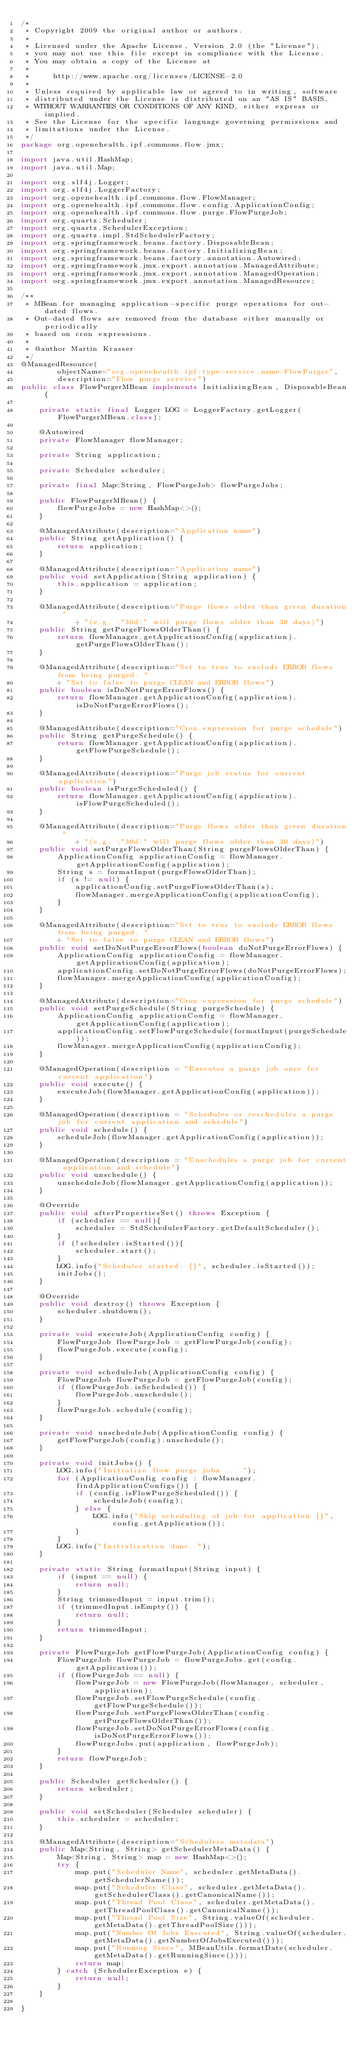Convert code to text. <code><loc_0><loc_0><loc_500><loc_500><_Java_>/*
 * Copyright 2009 the original author or authors.
 * 
 * Licensed under the Apache License, Version 2.0 (the "License");
 * you may not use this file except in compliance with the License.
 * You may obtain a copy of the License at
 *
 *     http://www.apache.org/licenses/LICENSE-2.0
 *     
 * Unless required by applicable law or agreed to in writing, software
 * distributed under the License is distributed on an "AS IS" BASIS,
 * WITHOUT WARRANTIES OR CONDITIONS OF ANY KIND, either express or implied.
 * See the License for the specific language governing permissions and
 * limitations under the License.
 */
package org.openehealth.ipf.commons.flow.jmx;

import java.util.HashMap;
import java.util.Map;

import org.slf4j.Logger;
import org.slf4j.LoggerFactory;
import org.openehealth.ipf.commons.flow.FlowManager;
import org.openehealth.ipf.commons.flow.config.ApplicationConfig;
import org.openehealth.ipf.commons.flow.purge.FlowPurgeJob;
import org.quartz.Scheduler;
import org.quartz.SchedulerException;
import org.quartz.impl.StdSchedulerFactory;
import org.springframework.beans.factory.DisposableBean;
import org.springframework.beans.factory.InitializingBean;
import org.springframework.beans.factory.annotation.Autowired;
import org.springframework.jmx.export.annotation.ManagedAttribute;
import org.springframework.jmx.export.annotation.ManagedOperation;
import org.springframework.jmx.export.annotation.ManagedResource;

/**
 * MBean for managing application-specific purge operations for out-dated flows.
 * Out-dated flows are removed from the database either manually or periodically
 * based on cron expressions.
 * 
 * @author Martin Krasser
 */
@ManagedResource(
        objectName="org.openehealth.ipf:type=service,name=FlowPurger",
        description="Flow purge service") 
public class FlowPurgerMBean implements InitializingBean, DisposableBean {

    private static final Logger LOG = LoggerFactory.getLogger(FlowPurgerMBean.class);

    @Autowired
    private FlowManager flowManager; 

    private String application; 

    private Scheduler scheduler;
    
    private final Map<String, FlowPurgeJob> flowPurgeJobs;

    public FlowPurgerMBean() {
        flowPurgeJobs = new HashMap<>();
    }

    @ManagedAttribute(description="Application name")
    public String getApplication() {
        return application;
    }

    @ManagedAttribute(description="Application name")
    public void setApplication(String application) {
        this.application = application;
    }

    @ManagedAttribute(description="Purge flows older than given duration "
            + "(e.g. \"30d\" will purge flows older than 30 days)")
    public String getPurgeFlowsOlderThan() {
        return flowManager.getApplicationConfig(application).getPurgeFlowsOlderThan();
    }

    @ManagedAttribute(description="Set to true to exclude ERROR flows from being purged. "
        + "Set to false to purge CLEAN and ERROR flows")
    public boolean isDoNotPurgeErrorFlows() {
        return flowManager.getApplicationConfig(application).isDoNotPurgeErrorFlows();
    }

    @ManagedAttribute(description="Cron expression for purge schedule")
    public String getPurgeSchedule() {
        return flowManager.getApplicationConfig(application).getFlowPurgeSchedule();
    }

    @ManagedAttribute(description="Purge job status for current application")
    public boolean isPurgeScheduled() {
        return flowManager.getApplicationConfig(application).isFlowPurgeScheduled();
    }

    @ManagedAttribute(description="Purge flows older than given duration "
            + "(e.g. \"30d\" will purge flows older than 30 days)")
    public void setPurgeFlowsOlderThan(String purgeFlowsOlderThan) {
        ApplicationConfig applicationConfig = flowManager.getApplicationConfig(application);
        String s = formatInput(purgeFlowsOlderThan);
        if (s != null) {
            applicationConfig.setPurgeFlowsOlderThan(s);
            flowManager.mergeApplicationConfig(applicationConfig);
        }
    }

    @ManagedAttribute(description="Set to true to exclude ERROR flows from being purged. "
        + "Set to false to purge CLEAN and ERROR flows")
    public void setDoNotPurgeErrorFlows(boolean doNotPurgeErrorFlows) {
        ApplicationConfig applicationConfig = flowManager.getApplicationConfig(application);
        applicationConfig.setDoNotPurgeErrorFlows(doNotPurgeErrorFlows);
        flowManager.mergeApplicationConfig(applicationConfig);
    }

    @ManagedAttribute(description="Cron expression for purge schedule")
    public void setPurgeSchedule(String purgeSchedule) {
        ApplicationConfig applicationConfig = flowManager.getApplicationConfig(application);
        applicationConfig.setFlowPurgeSchedule(formatInput(purgeSchedule));
        flowManager.mergeApplicationConfig(applicationConfig);
    }

    @ManagedOperation(description = "Executes a purge job once for current application")
    public void execute() {
        executeJob(flowManager.getApplicationConfig(application));
    }

    @ManagedOperation(description = "Schedules or reschedules a purge job for current application and schedule")
    public void schedule() {
        scheduleJob(flowManager.getApplicationConfig(application));
    }

    @ManagedOperation(description = "Unschedules a purge job for current application and schedule")
    public void unschedule() {
        unscheduleJob(flowManager.getApplicationConfig(application));
    }

    @Override
    public void afterPropertiesSet() throws Exception {
        if (scheduler == null){
    	    scheduler = StdSchedulerFactory.getDefaultScheduler();
        }
    	if (!scheduler.isStarted()){ 
            scheduler.start();
        }
        LOG.info("Scheduler started: {}", scheduler.isStarted());
        initJobs();
    }

    @Override
    public void destroy() throws Exception {
        scheduler.shutdown();
    }

    private void executeJob(ApplicationConfig config) {
        FlowPurgeJob flowPurgeJob = getFlowPurgeJob(config);
        flowPurgeJob.execute(config);
    }

    private void scheduleJob(ApplicationConfig config) {
        FlowPurgeJob flowPurgeJob = getFlowPurgeJob(config);
        if (flowPurgeJob.isScheduled()) {
            flowPurgeJob.unschedule();
        }
        flowPurgeJob.schedule(config);
    }

    private void unscheduleJob(ApplicationConfig config) {
        getFlowPurgeJob(config).unschedule();
    }

    private void initJobs() {
        LOG.info("Initialize flow purge jobs ... ");
        for (ApplicationConfig config : flowManager.findApplicationConfigs()) {
            if (config.isFlowPurgeScheduled()) {
                scheduleJob(config);
            } else {
                LOG.info("Skip scheduling of job for application {}", config.getApplication());
            }
        }
        LOG.info("Initialization done. ");
    }

    private static String formatInput(String input) {
        if (input == null) {
            return null;
        }
        String trimmedInput = input.trim();
        if (trimmedInput.isEmpty()) {
            return null;
        }
        return trimmedInput;
    }

    private FlowPurgeJob getFlowPurgeJob(ApplicationConfig config) {
        FlowPurgeJob flowPurgeJob = flowPurgeJobs.get(config.getApplication());
        if (flowPurgeJob == null) {
            flowPurgeJob = new FlowPurgeJob(flowManager, scheduler, application);
            flowPurgeJob.setFlowPurgeSchedule(config.getFlowPurgeSchedule());
            flowPurgeJob.setPurgeFlowsOlderThan(config.getPurgeFlowsOlderThan());
            flowPurgeJob.setDoNotPurgeErrorFlows(config.isDoNotPurgeErrorFlows());
            flowPurgeJobs.put(application, flowPurgeJob);
        }
        return flowPurgeJob;
    }

    public Scheduler getScheduler() {
        return scheduler;
    }

    public void setScheduler(Scheduler scheduler) {
        this.scheduler = scheduler;
    }

    @ManagedAttribute(description="Schedulers metadata")
    public Map<String, String> getSchedulerMetaData() {
        Map<String, String> map = new HashMap<>();
        try {
            map.put("Scheduler Name", scheduler.getMetaData().getSchedulerName());
            map.put("Scheduler Class", scheduler.getMetaData().getSchedulerClass().getCanonicalName());
            map.put("Thread Pool Class", scheduler.getMetaData().getThreadPoolClass().getCanonicalName());
            map.put("Thread Pool Size", String.valueOf(scheduler.getMetaData().getThreadPoolSize()));
            map.put("Number Of Jobs Executed", String.valueOf(scheduler.getMetaData().getNumberOfJobsExecuted()));
            map.put("Running Since", MBeanUtils.formatDate(scheduler.getMetaData().getRunningSince()));
            return map;
        } catch (SchedulerException e) {
            return null;
        }
    }

}
</code> 